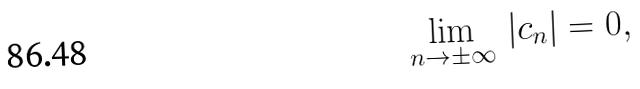<formula> <loc_0><loc_0><loc_500><loc_500>\lim _ { n \to \pm \infty } \, | c _ { n } | = 0 ,</formula> 